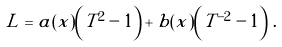<formula> <loc_0><loc_0><loc_500><loc_500>L = a ( x ) \left ( T ^ { 2 } - 1 \right ) + b ( x ) \left ( T ^ { - 2 } - 1 \right ) \, .</formula> 